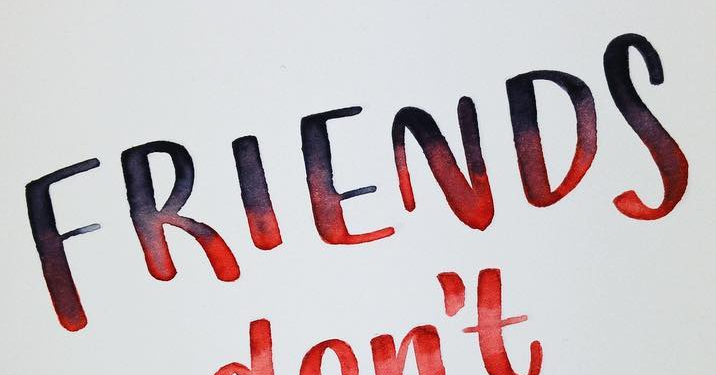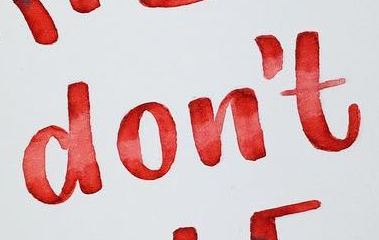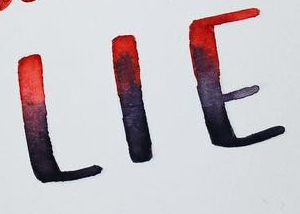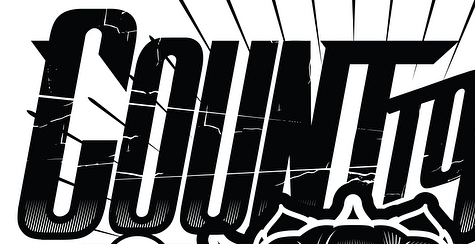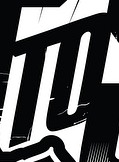What text appears in these images from left to right, separated by a semicolon? FRIENDS; don't; LIE; COUNT; TO 